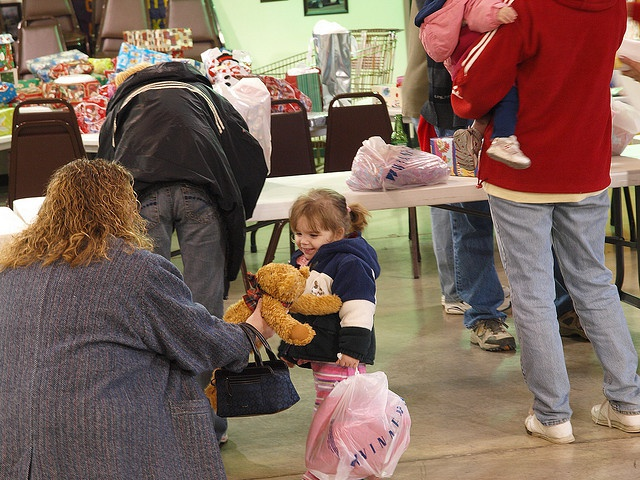Describe the objects in this image and their specific colors. I can see people in tan, gray, black, maroon, and brown tones, people in tan, maroon, darkgray, and gray tones, people in tan, black, and gray tones, dining table in tan, ivory, darkgray, and gray tones, and people in tan, black, brown, navy, and maroon tones in this image. 